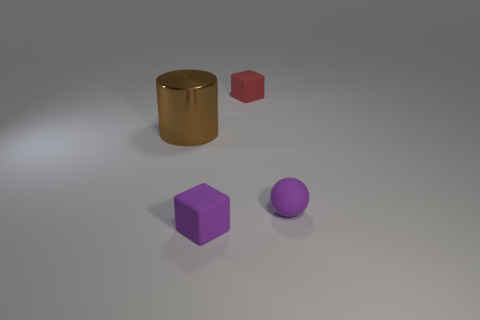What number of red cubes are to the left of the big metallic object?
Give a very brief answer. 0. What is the color of the tiny cube left of the small red rubber thing?
Your answer should be compact. Purple. There is another tiny matte thing that is the same shape as the tiny red matte thing; what color is it?
Your answer should be compact. Purple. Is there any other thing of the same color as the big shiny object?
Your answer should be compact. No. Is the number of cylinders greater than the number of blue rubber blocks?
Ensure brevity in your answer.  Yes. Do the small sphere and the big brown cylinder have the same material?
Your answer should be compact. No. What number of other spheres are the same material as the ball?
Make the answer very short. 0. Does the metal cylinder have the same size as the purple thing to the left of the small purple ball?
Offer a terse response. No. The object that is both to the left of the red matte cube and right of the cylinder is what color?
Your answer should be compact. Purple. There is a rubber object that is in front of the purple sphere; are there any brown cylinders that are in front of it?
Your answer should be compact. No. 